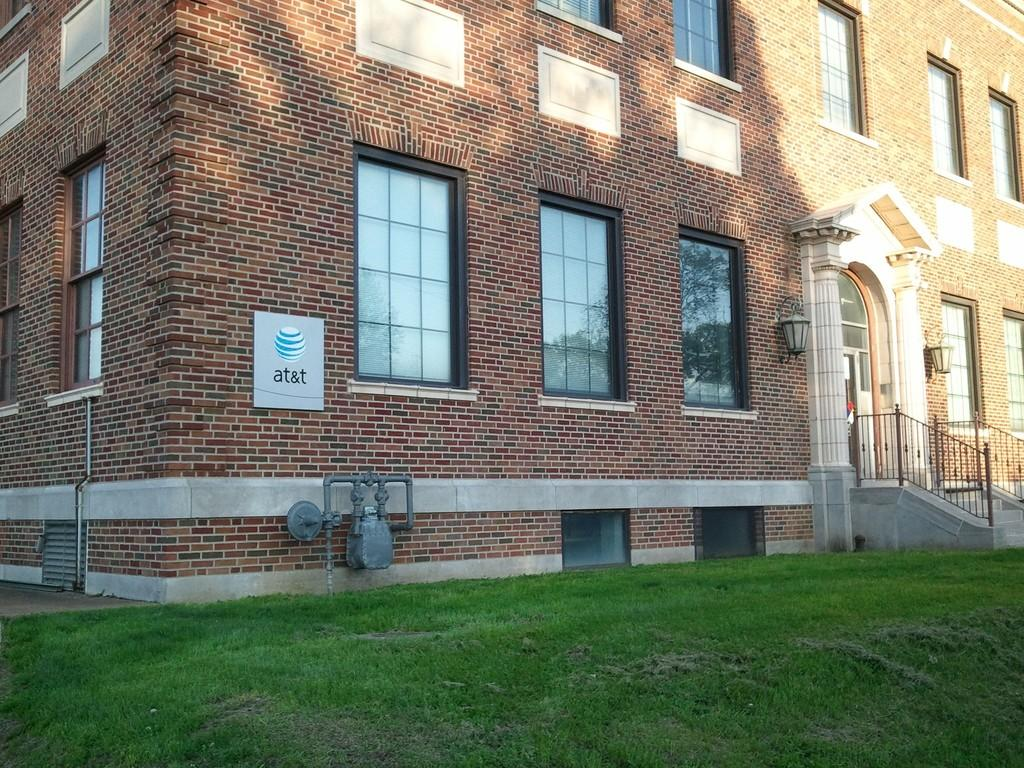What is the main structure visible in the image? There is a building in the image. What feature of the building is mentioned in the facts? The building has many windows. What type of surface is in front of the building? There is a grass ground in front of the building. What type of creature can be seen stitching a unit on the building in the image? There is no creature present in the image, and no unit is being stitched on the building. 